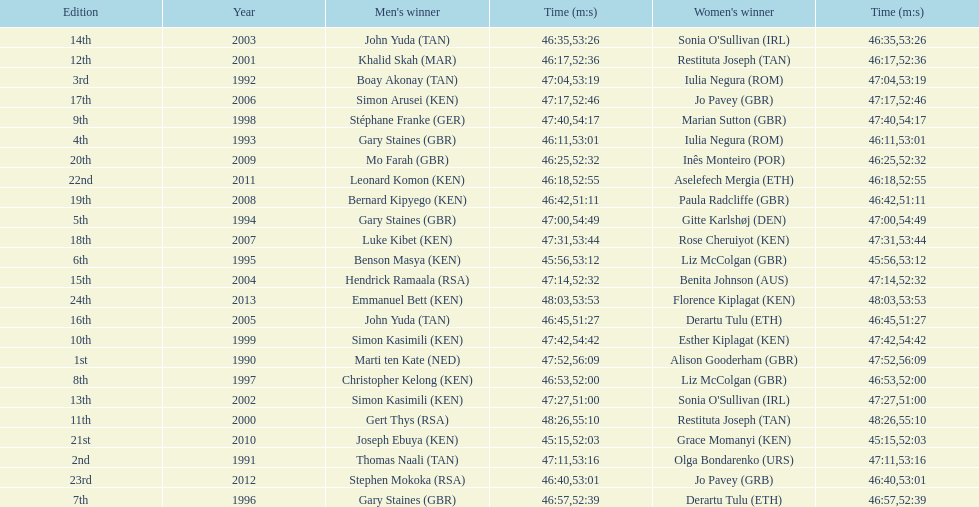How long did sonia o'sullivan take to finish in 2003? 53:26. 